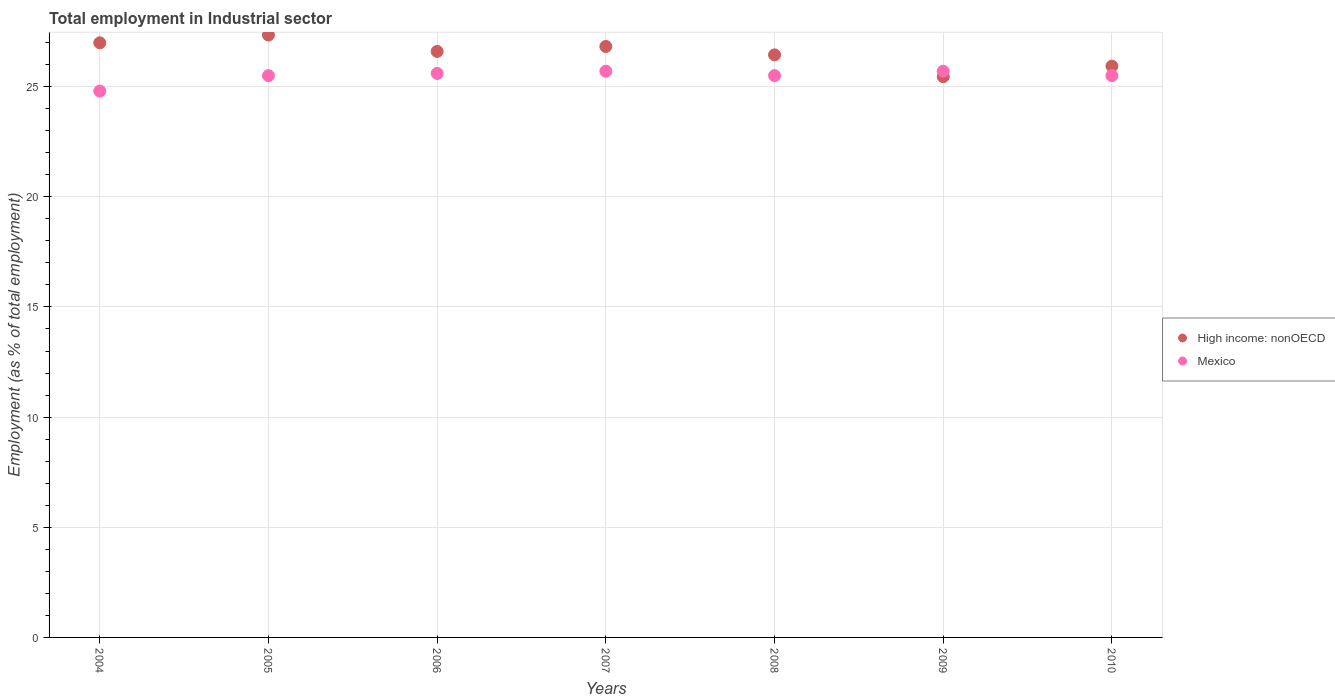How many different coloured dotlines are there?
Give a very brief answer. 2. What is the employment in industrial sector in Mexico in 2009?
Your response must be concise. 25.7. Across all years, what is the maximum employment in industrial sector in High income: nonOECD?
Offer a very short reply. 27.34. Across all years, what is the minimum employment in industrial sector in Mexico?
Ensure brevity in your answer.  24.8. In which year was the employment in industrial sector in High income: nonOECD maximum?
Your answer should be very brief. 2005. What is the total employment in industrial sector in Mexico in the graph?
Offer a terse response. 178.3. What is the difference between the employment in industrial sector in Mexico in 2004 and that in 2008?
Offer a very short reply. -0.7. What is the difference between the employment in industrial sector in Mexico in 2005 and the employment in industrial sector in High income: nonOECD in 2010?
Ensure brevity in your answer.  -0.43. What is the average employment in industrial sector in Mexico per year?
Your answer should be very brief. 25.47. In the year 2010, what is the difference between the employment in industrial sector in High income: nonOECD and employment in industrial sector in Mexico?
Your answer should be compact. 0.43. What is the ratio of the employment in industrial sector in High income: nonOECD in 2005 to that in 2006?
Your response must be concise. 1.03. Is the difference between the employment in industrial sector in High income: nonOECD in 2006 and 2008 greater than the difference between the employment in industrial sector in Mexico in 2006 and 2008?
Provide a short and direct response. Yes. What is the difference between the highest and the lowest employment in industrial sector in Mexico?
Your answer should be compact. 0.9. Is the employment in industrial sector in Mexico strictly less than the employment in industrial sector in High income: nonOECD over the years?
Provide a short and direct response. No. Does the graph contain any zero values?
Offer a terse response. No. Does the graph contain grids?
Make the answer very short. Yes. Where does the legend appear in the graph?
Your response must be concise. Center right. What is the title of the graph?
Your answer should be very brief. Total employment in Industrial sector. What is the label or title of the Y-axis?
Ensure brevity in your answer.  Employment (as % of total employment). What is the Employment (as % of total employment) in High income: nonOECD in 2004?
Your response must be concise. 26.99. What is the Employment (as % of total employment) of Mexico in 2004?
Your answer should be very brief. 24.8. What is the Employment (as % of total employment) in High income: nonOECD in 2005?
Your answer should be very brief. 27.34. What is the Employment (as % of total employment) in Mexico in 2005?
Provide a short and direct response. 25.5. What is the Employment (as % of total employment) in High income: nonOECD in 2006?
Your response must be concise. 26.6. What is the Employment (as % of total employment) in Mexico in 2006?
Ensure brevity in your answer.  25.6. What is the Employment (as % of total employment) of High income: nonOECD in 2007?
Offer a very short reply. 26.82. What is the Employment (as % of total employment) of Mexico in 2007?
Give a very brief answer. 25.7. What is the Employment (as % of total employment) in High income: nonOECD in 2008?
Your answer should be compact. 26.44. What is the Employment (as % of total employment) in Mexico in 2008?
Provide a short and direct response. 25.5. What is the Employment (as % of total employment) of High income: nonOECD in 2009?
Keep it short and to the point. 25.45. What is the Employment (as % of total employment) of Mexico in 2009?
Provide a short and direct response. 25.7. What is the Employment (as % of total employment) in High income: nonOECD in 2010?
Ensure brevity in your answer.  25.93. What is the Employment (as % of total employment) in Mexico in 2010?
Keep it short and to the point. 25.5. Across all years, what is the maximum Employment (as % of total employment) of High income: nonOECD?
Keep it short and to the point. 27.34. Across all years, what is the maximum Employment (as % of total employment) in Mexico?
Provide a short and direct response. 25.7. Across all years, what is the minimum Employment (as % of total employment) in High income: nonOECD?
Ensure brevity in your answer.  25.45. Across all years, what is the minimum Employment (as % of total employment) in Mexico?
Your answer should be compact. 24.8. What is the total Employment (as % of total employment) of High income: nonOECD in the graph?
Make the answer very short. 185.58. What is the total Employment (as % of total employment) in Mexico in the graph?
Your answer should be compact. 178.3. What is the difference between the Employment (as % of total employment) in High income: nonOECD in 2004 and that in 2005?
Keep it short and to the point. -0.35. What is the difference between the Employment (as % of total employment) in Mexico in 2004 and that in 2005?
Provide a succinct answer. -0.7. What is the difference between the Employment (as % of total employment) of High income: nonOECD in 2004 and that in 2006?
Offer a terse response. 0.39. What is the difference between the Employment (as % of total employment) in High income: nonOECD in 2004 and that in 2008?
Provide a short and direct response. 0.55. What is the difference between the Employment (as % of total employment) of Mexico in 2004 and that in 2008?
Your response must be concise. -0.7. What is the difference between the Employment (as % of total employment) in High income: nonOECD in 2004 and that in 2009?
Offer a very short reply. 1.54. What is the difference between the Employment (as % of total employment) of High income: nonOECD in 2004 and that in 2010?
Keep it short and to the point. 1.06. What is the difference between the Employment (as % of total employment) in Mexico in 2004 and that in 2010?
Offer a very short reply. -0.7. What is the difference between the Employment (as % of total employment) in High income: nonOECD in 2005 and that in 2006?
Ensure brevity in your answer.  0.74. What is the difference between the Employment (as % of total employment) in High income: nonOECD in 2005 and that in 2007?
Make the answer very short. 0.52. What is the difference between the Employment (as % of total employment) of High income: nonOECD in 2005 and that in 2008?
Ensure brevity in your answer.  0.9. What is the difference between the Employment (as % of total employment) of Mexico in 2005 and that in 2008?
Provide a short and direct response. 0. What is the difference between the Employment (as % of total employment) in High income: nonOECD in 2005 and that in 2009?
Your response must be concise. 1.89. What is the difference between the Employment (as % of total employment) of Mexico in 2005 and that in 2009?
Offer a very short reply. -0.2. What is the difference between the Employment (as % of total employment) of High income: nonOECD in 2005 and that in 2010?
Provide a short and direct response. 1.41. What is the difference between the Employment (as % of total employment) in High income: nonOECD in 2006 and that in 2007?
Ensure brevity in your answer.  -0.22. What is the difference between the Employment (as % of total employment) in Mexico in 2006 and that in 2007?
Your answer should be compact. -0.1. What is the difference between the Employment (as % of total employment) in High income: nonOECD in 2006 and that in 2008?
Make the answer very short. 0.16. What is the difference between the Employment (as % of total employment) in Mexico in 2006 and that in 2008?
Provide a succinct answer. 0.1. What is the difference between the Employment (as % of total employment) of High income: nonOECD in 2006 and that in 2009?
Give a very brief answer. 1.15. What is the difference between the Employment (as % of total employment) of High income: nonOECD in 2006 and that in 2010?
Make the answer very short. 0.67. What is the difference between the Employment (as % of total employment) of Mexico in 2006 and that in 2010?
Your answer should be compact. 0.1. What is the difference between the Employment (as % of total employment) of High income: nonOECD in 2007 and that in 2008?
Your answer should be very brief. 0.38. What is the difference between the Employment (as % of total employment) of High income: nonOECD in 2007 and that in 2009?
Offer a terse response. 1.37. What is the difference between the Employment (as % of total employment) of Mexico in 2007 and that in 2009?
Offer a very short reply. 0. What is the difference between the Employment (as % of total employment) in High income: nonOECD in 2007 and that in 2010?
Ensure brevity in your answer.  0.89. What is the difference between the Employment (as % of total employment) in High income: nonOECD in 2008 and that in 2009?
Your response must be concise. 0.99. What is the difference between the Employment (as % of total employment) in High income: nonOECD in 2008 and that in 2010?
Offer a very short reply. 0.51. What is the difference between the Employment (as % of total employment) in High income: nonOECD in 2009 and that in 2010?
Offer a terse response. -0.48. What is the difference between the Employment (as % of total employment) in High income: nonOECD in 2004 and the Employment (as % of total employment) in Mexico in 2005?
Your response must be concise. 1.49. What is the difference between the Employment (as % of total employment) in High income: nonOECD in 2004 and the Employment (as % of total employment) in Mexico in 2006?
Offer a very short reply. 1.39. What is the difference between the Employment (as % of total employment) in High income: nonOECD in 2004 and the Employment (as % of total employment) in Mexico in 2007?
Your answer should be very brief. 1.29. What is the difference between the Employment (as % of total employment) of High income: nonOECD in 2004 and the Employment (as % of total employment) of Mexico in 2008?
Make the answer very short. 1.49. What is the difference between the Employment (as % of total employment) in High income: nonOECD in 2004 and the Employment (as % of total employment) in Mexico in 2009?
Give a very brief answer. 1.29. What is the difference between the Employment (as % of total employment) of High income: nonOECD in 2004 and the Employment (as % of total employment) of Mexico in 2010?
Offer a terse response. 1.49. What is the difference between the Employment (as % of total employment) of High income: nonOECD in 2005 and the Employment (as % of total employment) of Mexico in 2006?
Keep it short and to the point. 1.74. What is the difference between the Employment (as % of total employment) in High income: nonOECD in 2005 and the Employment (as % of total employment) in Mexico in 2007?
Ensure brevity in your answer.  1.64. What is the difference between the Employment (as % of total employment) of High income: nonOECD in 2005 and the Employment (as % of total employment) of Mexico in 2008?
Offer a very short reply. 1.84. What is the difference between the Employment (as % of total employment) in High income: nonOECD in 2005 and the Employment (as % of total employment) in Mexico in 2009?
Give a very brief answer. 1.64. What is the difference between the Employment (as % of total employment) in High income: nonOECD in 2005 and the Employment (as % of total employment) in Mexico in 2010?
Offer a terse response. 1.84. What is the difference between the Employment (as % of total employment) of High income: nonOECD in 2006 and the Employment (as % of total employment) of Mexico in 2007?
Give a very brief answer. 0.9. What is the difference between the Employment (as % of total employment) of High income: nonOECD in 2006 and the Employment (as % of total employment) of Mexico in 2008?
Offer a very short reply. 1.1. What is the difference between the Employment (as % of total employment) in High income: nonOECD in 2006 and the Employment (as % of total employment) in Mexico in 2009?
Give a very brief answer. 0.9. What is the difference between the Employment (as % of total employment) in High income: nonOECD in 2006 and the Employment (as % of total employment) in Mexico in 2010?
Ensure brevity in your answer.  1.1. What is the difference between the Employment (as % of total employment) of High income: nonOECD in 2007 and the Employment (as % of total employment) of Mexico in 2008?
Give a very brief answer. 1.32. What is the difference between the Employment (as % of total employment) in High income: nonOECD in 2007 and the Employment (as % of total employment) in Mexico in 2009?
Ensure brevity in your answer.  1.12. What is the difference between the Employment (as % of total employment) of High income: nonOECD in 2007 and the Employment (as % of total employment) of Mexico in 2010?
Provide a succinct answer. 1.32. What is the difference between the Employment (as % of total employment) in High income: nonOECD in 2008 and the Employment (as % of total employment) in Mexico in 2009?
Provide a short and direct response. 0.74. What is the difference between the Employment (as % of total employment) in High income: nonOECD in 2008 and the Employment (as % of total employment) in Mexico in 2010?
Keep it short and to the point. 0.94. What is the difference between the Employment (as % of total employment) in High income: nonOECD in 2009 and the Employment (as % of total employment) in Mexico in 2010?
Your answer should be compact. -0.05. What is the average Employment (as % of total employment) in High income: nonOECD per year?
Provide a succinct answer. 26.51. What is the average Employment (as % of total employment) in Mexico per year?
Make the answer very short. 25.47. In the year 2004, what is the difference between the Employment (as % of total employment) in High income: nonOECD and Employment (as % of total employment) in Mexico?
Offer a terse response. 2.19. In the year 2005, what is the difference between the Employment (as % of total employment) in High income: nonOECD and Employment (as % of total employment) in Mexico?
Your answer should be compact. 1.84. In the year 2007, what is the difference between the Employment (as % of total employment) in High income: nonOECD and Employment (as % of total employment) in Mexico?
Your answer should be compact. 1.12. In the year 2008, what is the difference between the Employment (as % of total employment) in High income: nonOECD and Employment (as % of total employment) in Mexico?
Keep it short and to the point. 0.94. In the year 2009, what is the difference between the Employment (as % of total employment) of High income: nonOECD and Employment (as % of total employment) of Mexico?
Provide a succinct answer. -0.25. In the year 2010, what is the difference between the Employment (as % of total employment) in High income: nonOECD and Employment (as % of total employment) in Mexico?
Your answer should be compact. 0.43. What is the ratio of the Employment (as % of total employment) in High income: nonOECD in 2004 to that in 2005?
Give a very brief answer. 0.99. What is the ratio of the Employment (as % of total employment) in Mexico in 2004 to that in 2005?
Your response must be concise. 0.97. What is the ratio of the Employment (as % of total employment) of High income: nonOECD in 2004 to that in 2006?
Ensure brevity in your answer.  1.01. What is the ratio of the Employment (as % of total employment) of Mexico in 2004 to that in 2006?
Offer a very short reply. 0.97. What is the ratio of the Employment (as % of total employment) of Mexico in 2004 to that in 2007?
Ensure brevity in your answer.  0.96. What is the ratio of the Employment (as % of total employment) in High income: nonOECD in 2004 to that in 2008?
Your answer should be very brief. 1.02. What is the ratio of the Employment (as % of total employment) in Mexico in 2004 to that in 2008?
Offer a very short reply. 0.97. What is the ratio of the Employment (as % of total employment) of High income: nonOECD in 2004 to that in 2009?
Keep it short and to the point. 1.06. What is the ratio of the Employment (as % of total employment) in High income: nonOECD in 2004 to that in 2010?
Your answer should be compact. 1.04. What is the ratio of the Employment (as % of total employment) of Mexico in 2004 to that in 2010?
Provide a succinct answer. 0.97. What is the ratio of the Employment (as % of total employment) in High income: nonOECD in 2005 to that in 2006?
Ensure brevity in your answer.  1.03. What is the ratio of the Employment (as % of total employment) of High income: nonOECD in 2005 to that in 2007?
Give a very brief answer. 1.02. What is the ratio of the Employment (as % of total employment) of High income: nonOECD in 2005 to that in 2008?
Your answer should be very brief. 1.03. What is the ratio of the Employment (as % of total employment) in High income: nonOECD in 2005 to that in 2009?
Ensure brevity in your answer.  1.07. What is the ratio of the Employment (as % of total employment) of High income: nonOECD in 2005 to that in 2010?
Ensure brevity in your answer.  1.05. What is the ratio of the Employment (as % of total employment) of Mexico in 2006 to that in 2007?
Give a very brief answer. 1. What is the ratio of the Employment (as % of total employment) in High income: nonOECD in 2006 to that in 2008?
Your answer should be compact. 1.01. What is the ratio of the Employment (as % of total employment) in High income: nonOECD in 2006 to that in 2009?
Ensure brevity in your answer.  1.04. What is the ratio of the Employment (as % of total employment) in High income: nonOECD in 2006 to that in 2010?
Give a very brief answer. 1.03. What is the ratio of the Employment (as % of total employment) in Mexico in 2006 to that in 2010?
Give a very brief answer. 1. What is the ratio of the Employment (as % of total employment) of High income: nonOECD in 2007 to that in 2008?
Your response must be concise. 1.01. What is the ratio of the Employment (as % of total employment) of Mexico in 2007 to that in 2008?
Ensure brevity in your answer.  1.01. What is the ratio of the Employment (as % of total employment) of High income: nonOECD in 2007 to that in 2009?
Your answer should be very brief. 1.05. What is the ratio of the Employment (as % of total employment) in Mexico in 2007 to that in 2009?
Make the answer very short. 1. What is the ratio of the Employment (as % of total employment) of High income: nonOECD in 2007 to that in 2010?
Ensure brevity in your answer.  1.03. What is the ratio of the Employment (as % of total employment) in Mexico in 2007 to that in 2010?
Keep it short and to the point. 1.01. What is the ratio of the Employment (as % of total employment) of High income: nonOECD in 2008 to that in 2009?
Keep it short and to the point. 1.04. What is the ratio of the Employment (as % of total employment) of High income: nonOECD in 2008 to that in 2010?
Your response must be concise. 1.02. What is the ratio of the Employment (as % of total employment) in Mexico in 2008 to that in 2010?
Provide a succinct answer. 1. What is the ratio of the Employment (as % of total employment) in High income: nonOECD in 2009 to that in 2010?
Your response must be concise. 0.98. What is the ratio of the Employment (as % of total employment) of Mexico in 2009 to that in 2010?
Your response must be concise. 1.01. What is the difference between the highest and the second highest Employment (as % of total employment) of High income: nonOECD?
Give a very brief answer. 0.35. What is the difference between the highest and the second highest Employment (as % of total employment) in Mexico?
Offer a terse response. 0. What is the difference between the highest and the lowest Employment (as % of total employment) of High income: nonOECD?
Ensure brevity in your answer.  1.89. 